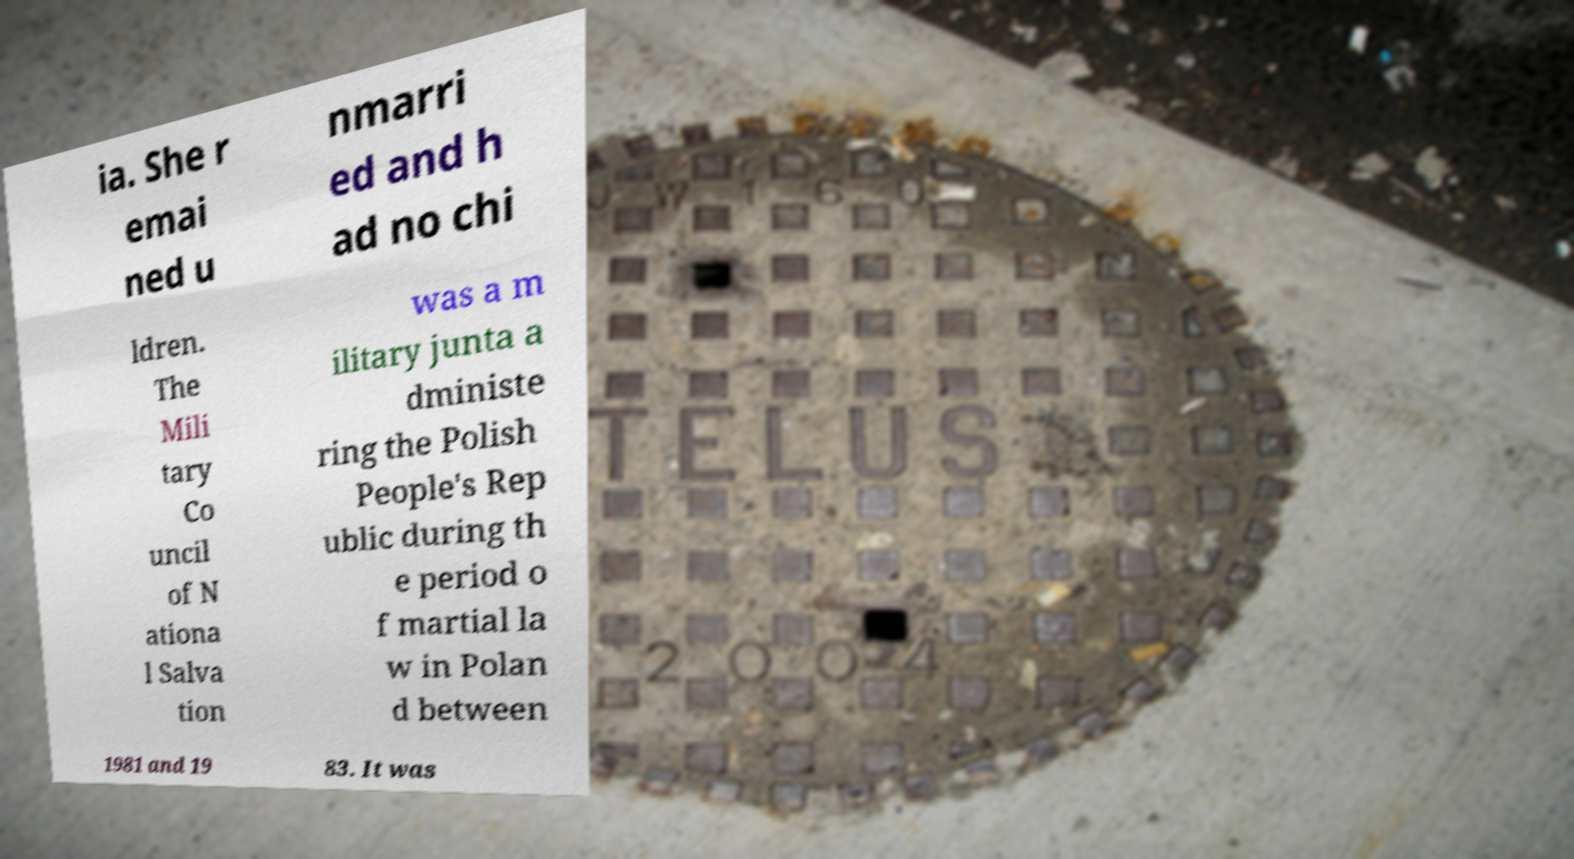I need the written content from this picture converted into text. Can you do that? ia. She r emai ned u nmarri ed and h ad no chi ldren. The Mili tary Co uncil of N ationa l Salva tion was a m ilitary junta a dministe ring the Polish People's Rep ublic during th e period o f martial la w in Polan d between 1981 and 19 83. It was 